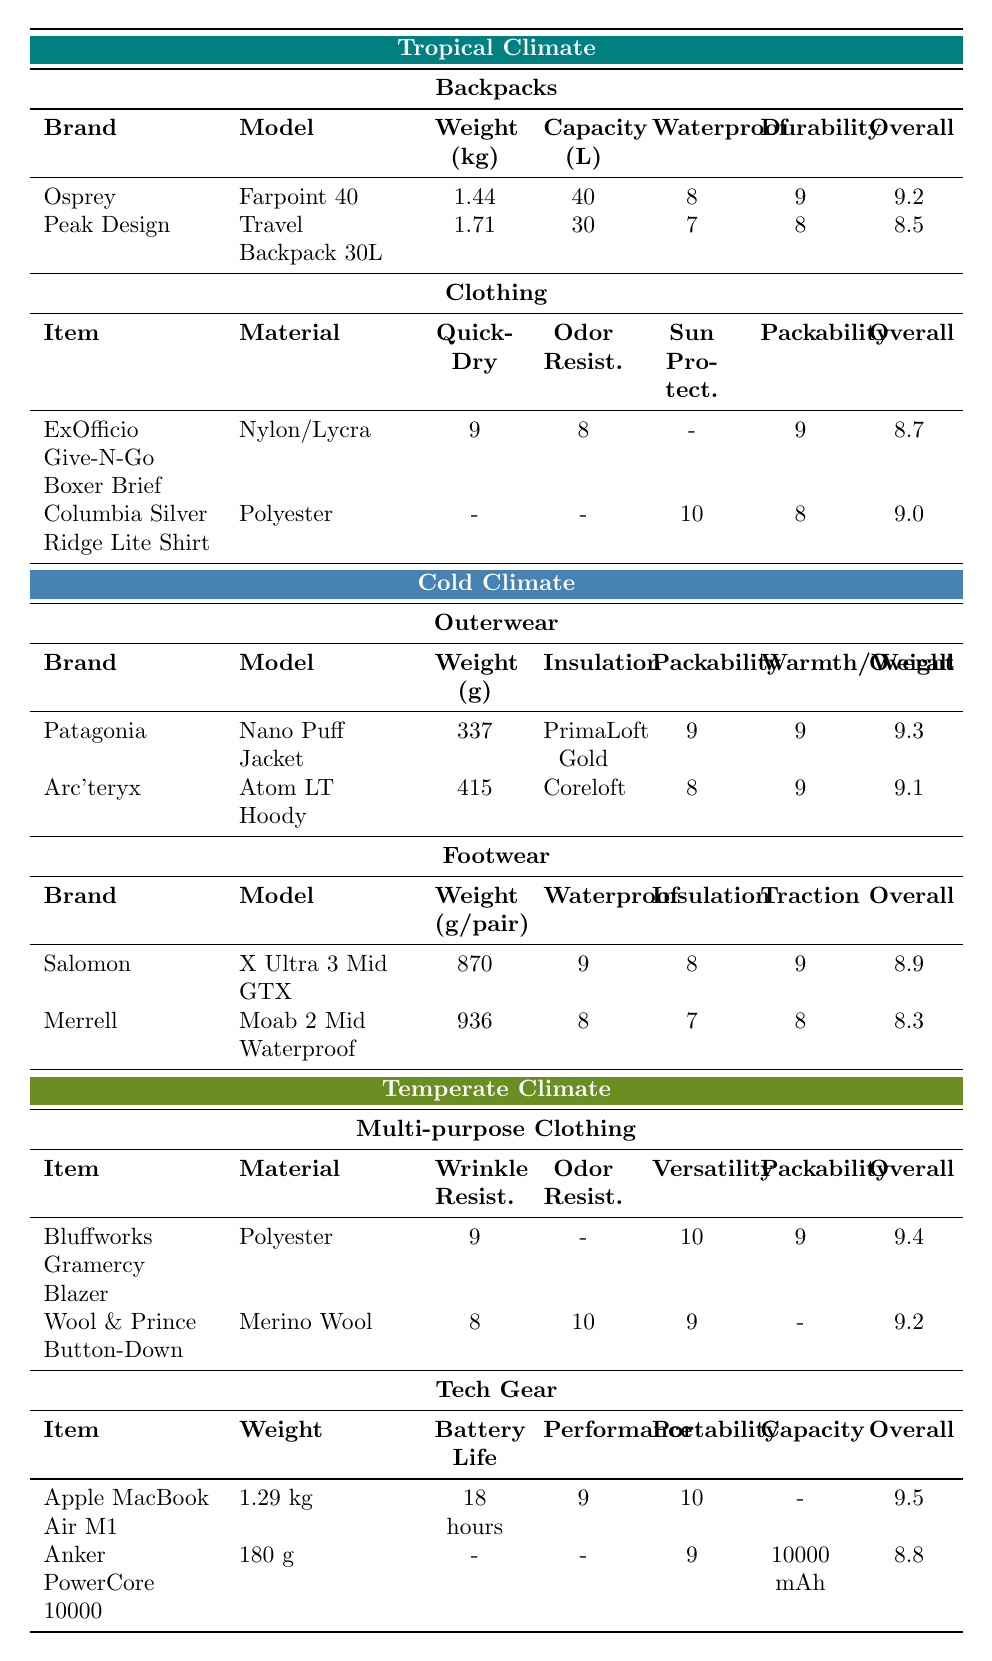What is the overall rating of the Osprey Farpoint 40 backpack? The table lists the Osprey Farpoint 40 backpack under the Tropical Climate in the Backpacks section, where the Overall Rating column shows a value of 9.2.
Answer: 9.2 Which brand has the highest overall rating for outerwear in a cold climate? In the Cold Climate section under Outerwear, the Patagonia Nano Puff Jacket has an Overall Rating of 9.3, which is higher than the Arc'teryx Atom LT Hoody's rating of 9.1.
Answer: Patagonia What is the weight difference between the lightest and heaviest backpack? The lightest backpack is the Osprey Farpoint 40 at 1.44 kg, and the heaviest is the Peak Design Travel Backpack 30L at 1.71 kg. The difference is calculated as 1.71 - 1.44 = 0.27 kg.
Answer: 0.27 kg Which tropical clothing item has the highest packability rating? Comparing the packability ratings for tropical clothing, the ExOfficio Give-N-Go Boxer Brief has a packability of 9, while the Columbia Silver Ridge Lite Shirt has a packability of 8.
Answer: ExOfficio Give-N-Go Boxer Brief What is the average overall rating of the tech gear in the temperate climate? In the Tech Gear section, the Apple MacBook Air M1 has an Overall Rating of 9.5 and the Anker PowerCore 10000 has a rating of 8.8. The average is calculated by summing these ratings (9.5 + 8.8 = 18.3) and dividing by 2, leading to an average of 18.3 / 2 = 9.15.
Answer: 9.15 Is the Columbia Silver Ridge Lite Long Sleeve Shirt more packable than the ExOfficio Give-N-Go Boxer Brief? The packability rating for the Columbia shirt is 8, while the ExOfficio boxer brief has a packability rating of 9. Since 9 is greater than 8, the statement is false.
Answer: No What is the total weight of the two cold climate footgear options? The Salomon X Ultra 3 Mid GTX weighs 870 g per pair and the Merrell Moab 2 Mid Waterproof weighs 936 g per pair. Adding these weights gives 870 + 936 = 1806 g.
Answer: 1806 g Which clothing item in the tropical climate offers the best sun protection? The Columbia Silver Ridge Lite Long Sleeve Shirt has a Sun Protection rating of 10, which is higher than any other clothing item in the tropical section.
Answer: Columbia Silver Ridge Lite Shirt Which gear, overall, has the best performance rating in the temperate climate tech section? The performance ratings are 9 for the Apple MacBook Air M1 and an unknown performance rating for the Anker PowerCore 10000 as it is missing. Therefore, the MacBook Air M1 has the best performance.
Answer: Apple MacBook Air M1 How does the overall rating of the Merrell Moab 2 Mid Waterproof compare to the Salomon X Ultra 3 Mid GTX? The Merrell Moab 2 Mid Waterproof has an Overall Rating of 8.3, while the Salomon X Ultra 3 Mid GTX has an Overall Rating of 8.9. Since 8.3 is less than 8.9, the Merrell has a lower rating.
Answer: Lower 